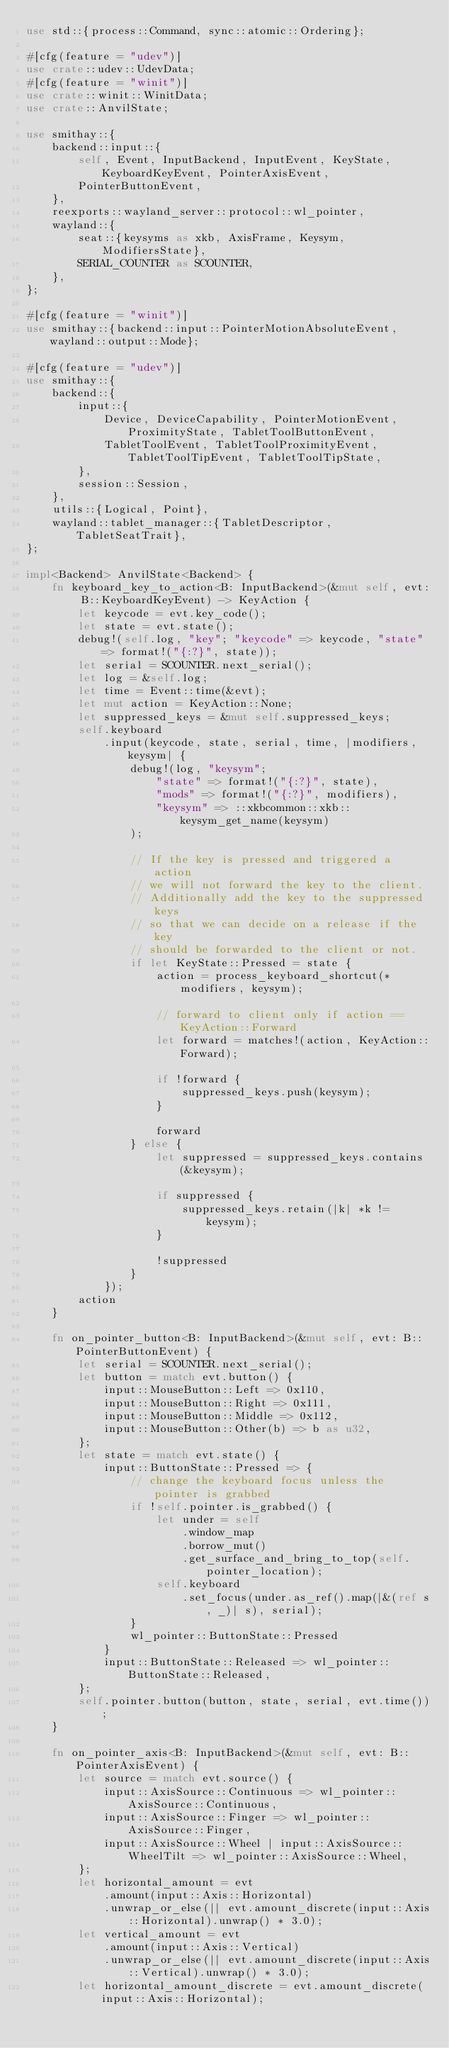Convert code to text. <code><loc_0><loc_0><loc_500><loc_500><_Rust_>use std::{process::Command, sync::atomic::Ordering};

#[cfg(feature = "udev")]
use crate::udev::UdevData;
#[cfg(feature = "winit")]
use crate::winit::WinitData;
use crate::AnvilState;

use smithay::{
    backend::input::{
        self, Event, InputBackend, InputEvent, KeyState, KeyboardKeyEvent, PointerAxisEvent,
        PointerButtonEvent,
    },
    reexports::wayland_server::protocol::wl_pointer,
    wayland::{
        seat::{keysyms as xkb, AxisFrame, Keysym, ModifiersState},
        SERIAL_COUNTER as SCOUNTER,
    },
};

#[cfg(feature = "winit")]
use smithay::{backend::input::PointerMotionAbsoluteEvent, wayland::output::Mode};

#[cfg(feature = "udev")]
use smithay::{
    backend::{
        input::{
            Device, DeviceCapability, PointerMotionEvent, ProximityState, TabletToolButtonEvent,
            TabletToolEvent, TabletToolProximityEvent, TabletToolTipEvent, TabletToolTipState,
        },
        session::Session,
    },
    utils::{Logical, Point},
    wayland::tablet_manager::{TabletDescriptor, TabletSeatTrait},
};

impl<Backend> AnvilState<Backend> {
    fn keyboard_key_to_action<B: InputBackend>(&mut self, evt: B::KeyboardKeyEvent) -> KeyAction {
        let keycode = evt.key_code();
        let state = evt.state();
        debug!(self.log, "key"; "keycode" => keycode, "state" => format!("{:?}", state));
        let serial = SCOUNTER.next_serial();
        let log = &self.log;
        let time = Event::time(&evt);
        let mut action = KeyAction::None;
        let suppressed_keys = &mut self.suppressed_keys;
        self.keyboard
            .input(keycode, state, serial, time, |modifiers, keysym| {
                debug!(log, "keysym";
                    "state" => format!("{:?}", state),
                    "mods" => format!("{:?}", modifiers),
                    "keysym" => ::xkbcommon::xkb::keysym_get_name(keysym)
                );

                // If the key is pressed and triggered a action
                // we will not forward the key to the client.
                // Additionally add the key to the suppressed keys
                // so that we can decide on a release if the key
                // should be forwarded to the client or not.
                if let KeyState::Pressed = state {
                    action = process_keyboard_shortcut(*modifiers, keysym);

                    // forward to client only if action == KeyAction::Forward
                    let forward = matches!(action, KeyAction::Forward);

                    if !forward {
                        suppressed_keys.push(keysym);
                    }

                    forward
                } else {
                    let suppressed = suppressed_keys.contains(&keysym);

                    if suppressed {
                        suppressed_keys.retain(|k| *k != keysym);
                    }

                    !suppressed
                }
            });
        action
    }

    fn on_pointer_button<B: InputBackend>(&mut self, evt: B::PointerButtonEvent) {
        let serial = SCOUNTER.next_serial();
        let button = match evt.button() {
            input::MouseButton::Left => 0x110,
            input::MouseButton::Right => 0x111,
            input::MouseButton::Middle => 0x112,
            input::MouseButton::Other(b) => b as u32,
        };
        let state = match evt.state() {
            input::ButtonState::Pressed => {
                // change the keyboard focus unless the pointer is grabbed
                if !self.pointer.is_grabbed() {
                    let under = self
                        .window_map
                        .borrow_mut()
                        .get_surface_and_bring_to_top(self.pointer_location);
                    self.keyboard
                        .set_focus(under.as_ref().map(|&(ref s, _)| s), serial);
                }
                wl_pointer::ButtonState::Pressed
            }
            input::ButtonState::Released => wl_pointer::ButtonState::Released,
        };
        self.pointer.button(button, state, serial, evt.time());
    }

    fn on_pointer_axis<B: InputBackend>(&mut self, evt: B::PointerAxisEvent) {
        let source = match evt.source() {
            input::AxisSource::Continuous => wl_pointer::AxisSource::Continuous,
            input::AxisSource::Finger => wl_pointer::AxisSource::Finger,
            input::AxisSource::Wheel | input::AxisSource::WheelTilt => wl_pointer::AxisSource::Wheel,
        };
        let horizontal_amount = evt
            .amount(input::Axis::Horizontal)
            .unwrap_or_else(|| evt.amount_discrete(input::Axis::Horizontal).unwrap() * 3.0);
        let vertical_amount = evt
            .amount(input::Axis::Vertical)
            .unwrap_or_else(|| evt.amount_discrete(input::Axis::Vertical).unwrap() * 3.0);
        let horizontal_amount_discrete = evt.amount_discrete(input::Axis::Horizontal);</code> 